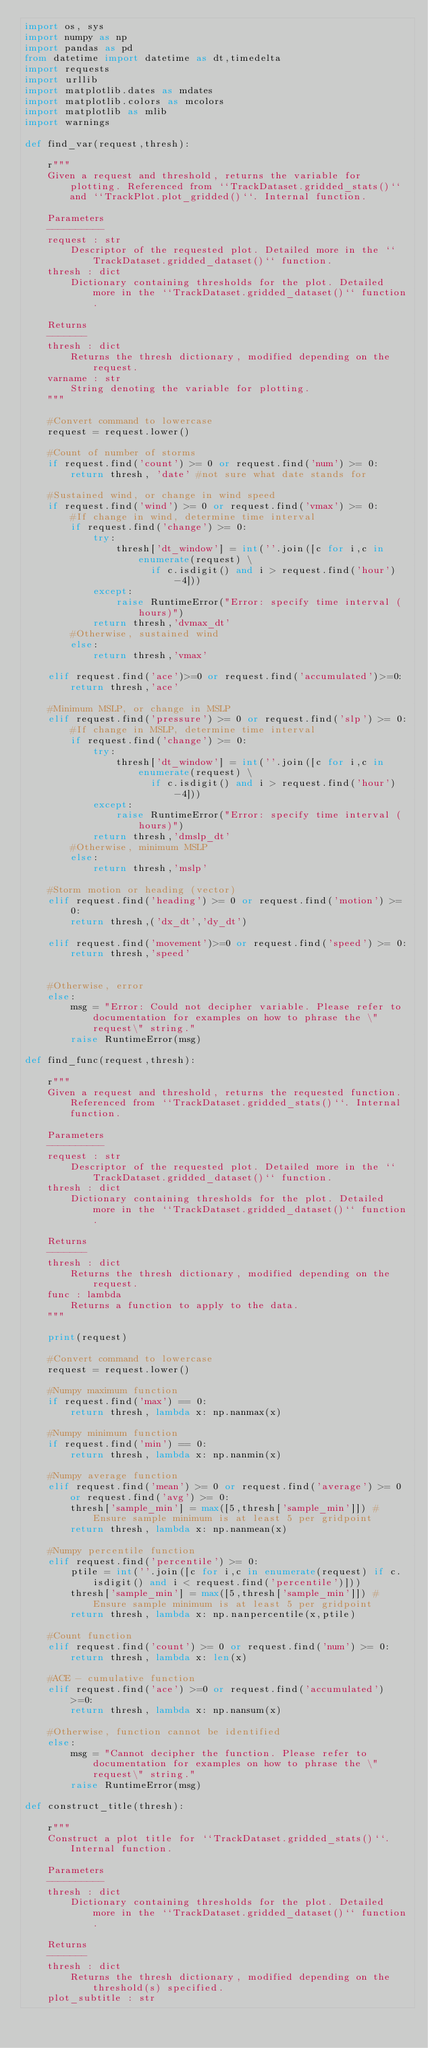Convert code to text. <code><loc_0><loc_0><loc_500><loc_500><_Python_>import os, sys
import numpy as np
import pandas as pd
from datetime import datetime as dt,timedelta
import requests
import urllib
import matplotlib.dates as mdates
import matplotlib.colors as mcolors
import matplotlib as mlib
import warnings

def find_var(request,thresh):
    
    r"""
    Given a request and threshold, returns the variable for plotting. Referenced from ``TrackDataset.gridded_stats()`` and ``TrackPlot.plot_gridded()``. Internal function.
    
    Parameters
    ----------
    request : str
        Descriptor of the requested plot. Detailed more in the ``TrackDataset.gridded_dataset()`` function.
    thresh : dict
        Dictionary containing thresholds for the plot. Detailed more in the ``TrackDataset.gridded_dataset()`` function.
    
    Returns
    -------
    thresh : dict
        Returns the thresh dictionary, modified depending on the request.
    varname : str
        String denoting the variable for plotting.
    """
    
    #Convert command to lowercase
    request = request.lower()
    
    #Count of number of storms
    if request.find('count') >= 0 or request.find('num') >= 0:
        return thresh, 'date' #not sure what date stands for
    
    #Sustained wind, or change in wind speed
    if request.find('wind') >= 0 or request.find('vmax') >= 0:
        #If change in wind, determine time interval
        if request.find('change') >= 0:
            try:
                thresh['dt_window'] = int(''.join([c for i,c in enumerate(request) \
                      if c.isdigit() and i > request.find('hour')-4]))
            except:
                raise RuntimeError("Error: specify time interval (hours)")
            return thresh,'dvmax_dt'
        #Otherwise, sustained wind
        else:
            return thresh,'vmax'

    elif request.find('ace')>=0 or request.find('accumulated')>=0:
        return thresh,'ace'
        
    #Minimum MSLP, or change in MSLP
    elif request.find('pressure') >= 0 or request.find('slp') >= 0:
        #If change in MSLP, determine time interval
        if request.find('change') >= 0:
            try:
                thresh['dt_window'] = int(''.join([c for i,c in enumerate(request) \
                      if c.isdigit() and i > request.find('hour')-4]))
            except:
                raise RuntimeError("Error: specify time interval (hours)")
            return thresh,'dmslp_dt'
        #Otherwise, minimum MSLP
        else:
            return thresh,'mslp'
    
    #Storm motion or heading (vector)
    elif request.find('heading') >= 0 or request.find('motion') >= 0:
        return thresh,('dx_dt','dy_dt')
    
    elif request.find('movement')>=0 or request.find('speed') >= 0:
        return thresh,'speed'
    
    
    #Otherwise, error
    else:
        msg = "Error: Could not decipher variable. Please refer to documentation for examples on how to phrase the \"request\" string."
        raise RuntimeError(msg)
        
def find_func(request,thresh):
    
    r"""
    Given a request and threshold, returns the requested function. Referenced from ``TrackDataset.gridded_stats()``. Internal function.
    
    Parameters
    ----------
    request : str
        Descriptor of the requested plot. Detailed more in the ``TrackDataset.gridded_dataset()`` function.
    thresh : dict
        Dictionary containing thresholds for the plot. Detailed more in the ``TrackDataset.gridded_dataset()`` function.
    
    Returns
    -------
    thresh : dict
        Returns the thresh dictionary, modified depending on the request.
    func : lambda
        Returns a function to apply to the data.
    """
    
    print(request)
    
    #Convert command to lowercase
    request = request.lower()
    
    #Numpy maximum function
    if request.find('max') == 0:
        return thresh, lambda x: np.nanmax(x)
    
    #Numpy minimum function
    if request.find('min') == 0:
        return thresh, lambda x: np.nanmin(x)
    
    #Numpy average function
    elif request.find('mean') >= 0 or request.find('average') >= 0 or request.find('avg') >= 0:
        thresh['sample_min'] = max([5,thresh['sample_min']]) #Ensure sample minimum is at least 5 per gridpoint
        return thresh, lambda x: np.nanmean(x)
    
    #Numpy percentile function
    elif request.find('percentile') >= 0:
        ptile = int(''.join([c for i,c in enumerate(request) if c.isdigit() and i < request.find('percentile')]))
        thresh['sample_min'] = max([5,thresh['sample_min']]) #Ensure sample minimum is at least 5 per gridpoint
        return thresh, lambda x: np.nanpercentile(x,ptile)
    
    #Count function
    elif request.find('count') >= 0 or request.find('num') >= 0:
        return thresh, lambda x: len(x)
    
    #ACE - cumulative function
    elif request.find('ace') >=0 or request.find('accumulated') >=0:
        return thresh, lambda x: np.nansum(x)
    
    #Otherwise, function cannot be identified
    else:
        msg = "Cannot decipher the function. Please refer to documentation for examples on how to phrase the \"request\" string."
        raise RuntimeError(msg)

def construct_title(thresh):
    
    r"""
    Construct a plot title for ``TrackDataset.gridded_stats()``. Internal function.
    
    Parameters
    ----------
    thresh : dict
        Dictionary containing thresholds for the plot. Detailed more in the ``TrackDataset.gridded_dataset()`` function.
    
    Returns
    -------
    thresh : dict
        Returns the thresh dictionary, modified depending on the threshold(s) specified.
    plot_subtitle : str</code> 